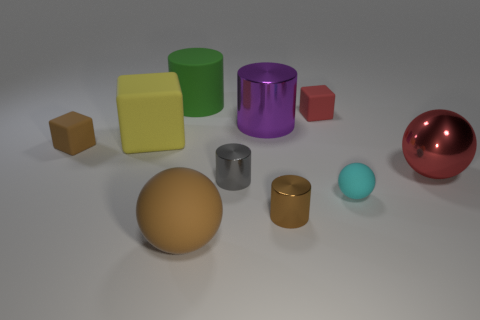What number of other things are there of the same material as the gray thing
Your answer should be compact. 3. Are the large object that is in front of the cyan ball and the red thing that is behind the large red metallic object made of the same material?
Your answer should be compact. Yes. What number of blocks are both right of the rubber cylinder and left of the big rubber cube?
Offer a terse response. 0. Is there a small shiny object of the same shape as the large green rubber thing?
Ensure brevity in your answer.  Yes. There is a brown matte thing that is the same size as the brown metal thing; what is its shape?
Give a very brief answer. Cube. Are there the same number of rubber things behind the tiny cyan rubber object and green matte cylinders that are to the right of the red matte cube?
Your response must be concise. No. How big is the brown matte object on the left side of the big rubber object behind the yellow block?
Keep it short and to the point. Small. Is there a yellow cylinder of the same size as the gray metallic thing?
Offer a terse response. No. There is a cylinder that is made of the same material as the cyan object; what color is it?
Ensure brevity in your answer.  Green. Is the number of small blue shiny cubes less than the number of gray cylinders?
Provide a succinct answer. Yes. 